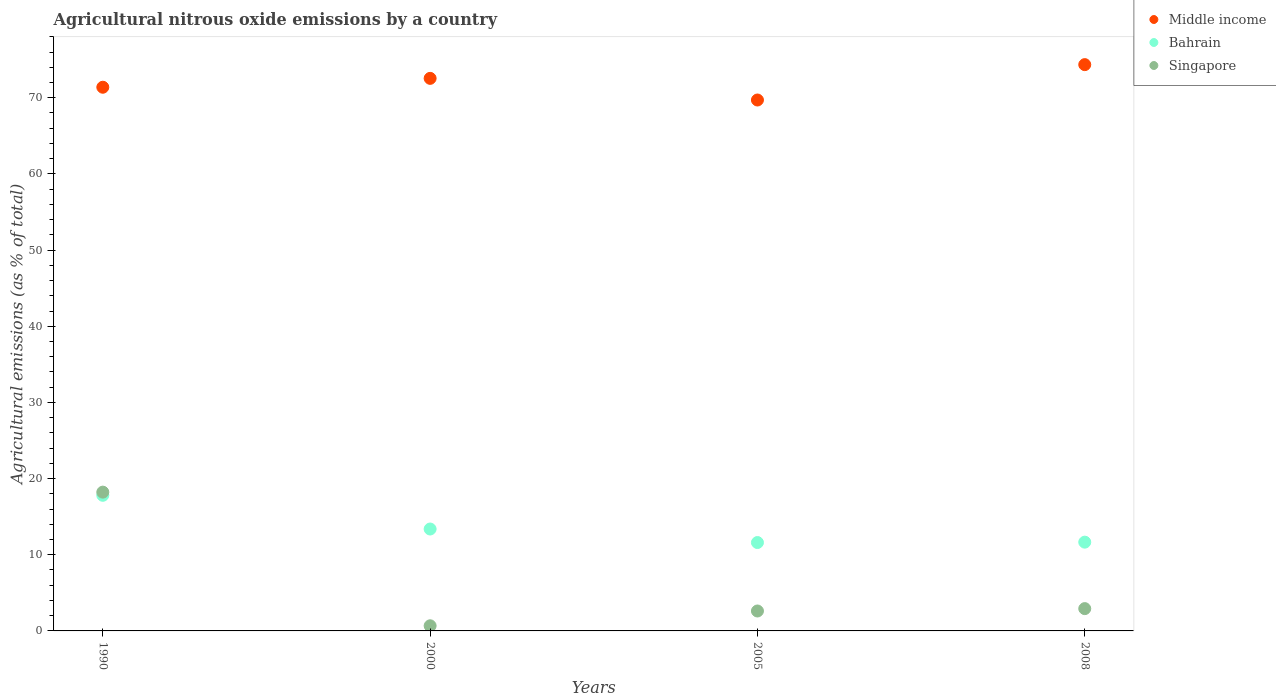Is the number of dotlines equal to the number of legend labels?
Offer a terse response. Yes. What is the amount of agricultural nitrous oxide emitted in Bahrain in 2005?
Your answer should be compact. 11.6. Across all years, what is the maximum amount of agricultural nitrous oxide emitted in Bahrain?
Offer a terse response. 17.81. Across all years, what is the minimum amount of agricultural nitrous oxide emitted in Singapore?
Your answer should be very brief. 0.67. In which year was the amount of agricultural nitrous oxide emitted in Middle income minimum?
Provide a short and direct response. 2005. What is the total amount of agricultural nitrous oxide emitted in Middle income in the graph?
Your answer should be very brief. 287.97. What is the difference between the amount of agricultural nitrous oxide emitted in Middle income in 2005 and that in 2008?
Make the answer very short. -4.64. What is the difference between the amount of agricultural nitrous oxide emitted in Middle income in 2000 and the amount of agricultural nitrous oxide emitted in Bahrain in 2008?
Your answer should be compact. 60.89. What is the average amount of agricultural nitrous oxide emitted in Bahrain per year?
Your answer should be compact. 13.61. In the year 2000, what is the difference between the amount of agricultural nitrous oxide emitted in Middle income and amount of agricultural nitrous oxide emitted in Singapore?
Keep it short and to the point. 71.87. In how many years, is the amount of agricultural nitrous oxide emitted in Singapore greater than 62 %?
Your response must be concise. 0. What is the ratio of the amount of agricultural nitrous oxide emitted in Middle income in 1990 to that in 2000?
Keep it short and to the point. 0.98. What is the difference between the highest and the second highest amount of agricultural nitrous oxide emitted in Middle income?
Offer a terse response. 1.8. What is the difference between the highest and the lowest amount of agricultural nitrous oxide emitted in Bahrain?
Provide a succinct answer. 6.2. Is the sum of the amount of agricultural nitrous oxide emitted in Middle income in 1990 and 2000 greater than the maximum amount of agricultural nitrous oxide emitted in Singapore across all years?
Your response must be concise. Yes. Is it the case that in every year, the sum of the amount of agricultural nitrous oxide emitted in Bahrain and amount of agricultural nitrous oxide emitted in Middle income  is greater than the amount of agricultural nitrous oxide emitted in Singapore?
Your answer should be very brief. Yes. Does the amount of agricultural nitrous oxide emitted in Middle income monotonically increase over the years?
Ensure brevity in your answer.  No. Is the amount of agricultural nitrous oxide emitted in Middle income strictly greater than the amount of agricultural nitrous oxide emitted in Bahrain over the years?
Offer a very short reply. Yes. What is the difference between two consecutive major ticks on the Y-axis?
Keep it short and to the point. 10. Are the values on the major ticks of Y-axis written in scientific E-notation?
Keep it short and to the point. No. Does the graph contain any zero values?
Provide a succinct answer. No. Does the graph contain grids?
Give a very brief answer. No. Where does the legend appear in the graph?
Your answer should be very brief. Top right. What is the title of the graph?
Make the answer very short. Agricultural nitrous oxide emissions by a country. What is the label or title of the X-axis?
Offer a very short reply. Years. What is the label or title of the Y-axis?
Offer a very short reply. Agricultural emissions (as % of total). What is the Agricultural emissions (as % of total) of Middle income in 1990?
Your answer should be compact. 71.38. What is the Agricultural emissions (as % of total) in Bahrain in 1990?
Offer a terse response. 17.81. What is the Agricultural emissions (as % of total) of Singapore in 1990?
Make the answer very short. 18.22. What is the Agricultural emissions (as % of total) in Middle income in 2000?
Make the answer very short. 72.54. What is the Agricultural emissions (as % of total) of Bahrain in 2000?
Keep it short and to the point. 13.38. What is the Agricultural emissions (as % of total) in Singapore in 2000?
Provide a succinct answer. 0.67. What is the Agricultural emissions (as % of total) in Middle income in 2005?
Offer a terse response. 69.7. What is the Agricultural emissions (as % of total) in Bahrain in 2005?
Provide a succinct answer. 11.6. What is the Agricultural emissions (as % of total) in Singapore in 2005?
Provide a short and direct response. 2.62. What is the Agricultural emissions (as % of total) in Middle income in 2008?
Your response must be concise. 74.35. What is the Agricultural emissions (as % of total) of Bahrain in 2008?
Provide a succinct answer. 11.65. What is the Agricultural emissions (as % of total) of Singapore in 2008?
Give a very brief answer. 2.93. Across all years, what is the maximum Agricultural emissions (as % of total) in Middle income?
Your answer should be compact. 74.35. Across all years, what is the maximum Agricultural emissions (as % of total) in Bahrain?
Provide a short and direct response. 17.81. Across all years, what is the maximum Agricultural emissions (as % of total) in Singapore?
Offer a very short reply. 18.22. Across all years, what is the minimum Agricultural emissions (as % of total) of Middle income?
Offer a terse response. 69.7. Across all years, what is the minimum Agricultural emissions (as % of total) of Bahrain?
Provide a short and direct response. 11.6. Across all years, what is the minimum Agricultural emissions (as % of total) in Singapore?
Make the answer very short. 0.67. What is the total Agricultural emissions (as % of total) in Middle income in the graph?
Your answer should be compact. 287.97. What is the total Agricultural emissions (as % of total) in Bahrain in the graph?
Give a very brief answer. 54.44. What is the total Agricultural emissions (as % of total) of Singapore in the graph?
Ensure brevity in your answer.  24.44. What is the difference between the Agricultural emissions (as % of total) of Middle income in 1990 and that in 2000?
Ensure brevity in your answer.  -1.17. What is the difference between the Agricultural emissions (as % of total) of Bahrain in 1990 and that in 2000?
Your answer should be compact. 4.43. What is the difference between the Agricultural emissions (as % of total) in Singapore in 1990 and that in 2000?
Make the answer very short. 17.55. What is the difference between the Agricultural emissions (as % of total) in Middle income in 1990 and that in 2005?
Your answer should be compact. 1.68. What is the difference between the Agricultural emissions (as % of total) of Bahrain in 1990 and that in 2005?
Make the answer very short. 6.2. What is the difference between the Agricultural emissions (as % of total) in Singapore in 1990 and that in 2005?
Your response must be concise. 15.6. What is the difference between the Agricultural emissions (as % of total) of Middle income in 1990 and that in 2008?
Your answer should be compact. -2.97. What is the difference between the Agricultural emissions (as % of total) of Bahrain in 1990 and that in 2008?
Provide a succinct answer. 6.15. What is the difference between the Agricultural emissions (as % of total) in Singapore in 1990 and that in 2008?
Your response must be concise. 15.29. What is the difference between the Agricultural emissions (as % of total) of Middle income in 2000 and that in 2005?
Your response must be concise. 2.84. What is the difference between the Agricultural emissions (as % of total) of Bahrain in 2000 and that in 2005?
Your response must be concise. 1.78. What is the difference between the Agricultural emissions (as % of total) of Singapore in 2000 and that in 2005?
Make the answer very short. -1.94. What is the difference between the Agricultural emissions (as % of total) of Middle income in 2000 and that in 2008?
Offer a very short reply. -1.8. What is the difference between the Agricultural emissions (as % of total) in Bahrain in 2000 and that in 2008?
Offer a very short reply. 1.72. What is the difference between the Agricultural emissions (as % of total) of Singapore in 2000 and that in 2008?
Provide a short and direct response. -2.25. What is the difference between the Agricultural emissions (as % of total) in Middle income in 2005 and that in 2008?
Keep it short and to the point. -4.64. What is the difference between the Agricultural emissions (as % of total) of Bahrain in 2005 and that in 2008?
Ensure brevity in your answer.  -0.05. What is the difference between the Agricultural emissions (as % of total) of Singapore in 2005 and that in 2008?
Your answer should be compact. -0.31. What is the difference between the Agricultural emissions (as % of total) of Middle income in 1990 and the Agricultural emissions (as % of total) of Bahrain in 2000?
Give a very brief answer. 58. What is the difference between the Agricultural emissions (as % of total) of Middle income in 1990 and the Agricultural emissions (as % of total) of Singapore in 2000?
Keep it short and to the point. 70.7. What is the difference between the Agricultural emissions (as % of total) of Bahrain in 1990 and the Agricultural emissions (as % of total) of Singapore in 2000?
Keep it short and to the point. 17.13. What is the difference between the Agricultural emissions (as % of total) in Middle income in 1990 and the Agricultural emissions (as % of total) in Bahrain in 2005?
Your answer should be very brief. 59.77. What is the difference between the Agricultural emissions (as % of total) of Middle income in 1990 and the Agricultural emissions (as % of total) of Singapore in 2005?
Provide a short and direct response. 68.76. What is the difference between the Agricultural emissions (as % of total) in Bahrain in 1990 and the Agricultural emissions (as % of total) in Singapore in 2005?
Provide a succinct answer. 15.19. What is the difference between the Agricultural emissions (as % of total) in Middle income in 1990 and the Agricultural emissions (as % of total) in Bahrain in 2008?
Your response must be concise. 59.72. What is the difference between the Agricultural emissions (as % of total) in Middle income in 1990 and the Agricultural emissions (as % of total) in Singapore in 2008?
Ensure brevity in your answer.  68.45. What is the difference between the Agricultural emissions (as % of total) in Bahrain in 1990 and the Agricultural emissions (as % of total) in Singapore in 2008?
Provide a succinct answer. 14.88. What is the difference between the Agricultural emissions (as % of total) in Middle income in 2000 and the Agricultural emissions (as % of total) in Bahrain in 2005?
Provide a succinct answer. 60.94. What is the difference between the Agricultural emissions (as % of total) of Middle income in 2000 and the Agricultural emissions (as % of total) of Singapore in 2005?
Give a very brief answer. 69.93. What is the difference between the Agricultural emissions (as % of total) of Bahrain in 2000 and the Agricultural emissions (as % of total) of Singapore in 2005?
Offer a very short reply. 10.76. What is the difference between the Agricultural emissions (as % of total) of Middle income in 2000 and the Agricultural emissions (as % of total) of Bahrain in 2008?
Provide a succinct answer. 60.89. What is the difference between the Agricultural emissions (as % of total) of Middle income in 2000 and the Agricultural emissions (as % of total) of Singapore in 2008?
Make the answer very short. 69.62. What is the difference between the Agricultural emissions (as % of total) of Bahrain in 2000 and the Agricultural emissions (as % of total) of Singapore in 2008?
Provide a short and direct response. 10.45. What is the difference between the Agricultural emissions (as % of total) of Middle income in 2005 and the Agricultural emissions (as % of total) of Bahrain in 2008?
Give a very brief answer. 58.05. What is the difference between the Agricultural emissions (as % of total) in Middle income in 2005 and the Agricultural emissions (as % of total) in Singapore in 2008?
Provide a succinct answer. 66.77. What is the difference between the Agricultural emissions (as % of total) in Bahrain in 2005 and the Agricultural emissions (as % of total) in Singapore in 2008?
Offer a terse response. 8.68. What is the average Agricultural emissions (as % of total) in Middle income per year?
Offer a terse response. 71.99. What is the average Agricultural emissions (as % of total) in Bahrain per year?
Keep it short and to the point. 13.61. What is the average Agricultural emissions (as % of total) in Singapore per year?
Offer a terse response. 6.11. In the year 1990, what is the difference between the Agricultural emissions (as % of total) of Middle income and Agricultural emissions (as % of total) of Bahrain?
Keep it short and to the point. 53.57. In the year 1990, what is the difference between the Agricultural emissions (as % of total) of Middle income and Agricultural emissions (as % of total) of Singapore?
Your answer should be compact. 53.16. In the year 1990, what is the difference between the Agricultural emissions (as % of total) of Bahrain and Agricultural emissions (as % of total) of Singapore?
Your response must be concise. -0.41. In the year 2000, what is the difference between the Agricultural emissions (as % of total) of Middle income and Agricultural emissions (as % of total) of Bahrain?
Provide a succinct answer. 59.16. In the year 2000, what is the difference between the Agricultural emissions (as % of total) in Middle income and Agricultural emissions (as % of total) in Singapore?
Offer a terse response. 71.87. In the year 2000, what is the difference between the Agricultural emissions (as % of total) in Bahrain and Agricultural emissions (as % of total) in Singapore?
Ensure brevity in your answer.  12.7. In the year 2005, what is the difference between the Agricultural emissions (as % of total) in Middle income and Agricultural emissions (as % of total) in Bahrain?
Ensure brevity in your answer.  58.1. In the year 2005, what is the difference between the Agricultural emissions (as % of total) of Middle income and Agricultural emissions (as % of total) of Singapore?
Provide a short and direct response. 67.09. In the year 2005, what is the difference between the Agricultural emissions (as % of total) of Bahrain and Agricultural emissions (as % of total) of Singapore?
Make the answer very short. 8.99. In the year 2008, what is the difference between the Agricultural emissions (as % of total) in Middle income and Agricultural emissions (as % of total) in Bahrain?
Your answer should be very brief. 62.69. In the year 2008, what is the difference between the Agricultural emissions (as % of total) in Middle income and Agricultural emissions (as % of total) in Singapore?
Make the answer very short. 71.42. In the year 2008, what is the difference between the Agricultural emissions (as % of total) of Bahrain and Agricultural emissions (as % of total) of Singapore?
Keep it short and to the point. 8.73. What is the ratio of the Agricultural emissions (as % of total) of Middle income in 1990 to that in 2000?
Make the answer very short. 0.98. What is the ratio of the Agricultural emissions (as % of total) of Bahrain in 1990 to that in 2000?
Your answer should be very brief. 1.33. What is the ratio of the Agricultural emissions (as % of total) of Singapore in 1990 to that in 2000?
Your answer should be very brief. 27.02. What is the ratio of the Agricultural emissions (as % of total) of Middle income in 1990 to that in 2005?
Your answer should be very brief. 1.02. What is the ratio of the Agricultural emissions (as % of total) in Bahrain in 1990 to that in 2005?
Provide a succinct answer. 1.53. What is the ratio of the Agricultural emissions (as % of total) in Singapore in 1990 to that in 2005?
Your response must be concise. 6.96. What is the ratio of the Agricultural emissions (as % of total) in Middle income in 1990 to that in 2008?
Provide a succinct answer. 0.96. What is the ratio of the Agricultural emissions (as % of total) of Bahrain in 1990 to that in 2008?
Keep it short and to the point. 1.53. What is the ratio of the Agricultural emissions (as % of total) of Singapore in 1990 to that in 2008?
Offer a terse response. 6.22. What is the ratio of the Agricultural emissions (as % of total) of Middle income in 2000 to that in 2005?
Provide a succinct answer. 1.04. What is the ratio of the Agricultural emissions (as % of total) of Bahrain in 2000 to that in 2005?
Offer a very short reply. 1.15. What is the ratio of the Agricultural emissions (as % of total) of Singapore in 2000 to that in 2005?
Ensure brevity in your answer.  0.26. What is the ratio of the Agricultural emissions (as % of total) of Middle income in 2000 to that in 2008?
Keep it short and to the point. 0.98. What is the ratio of the Agricultural emissions (as % of total) of Bahrain in 2000 to that in 2008?
Provide a succinct answer. 1.15. What is the ratio of the Agricultural emissions (as % of total) of Singapore in 2000 to that in 2008?
Your answer should be very brief. 0.23. What is the ratio of the Agricultural emissions (as % of total) of Middle income in 2005 to that in 2008?
Provide a succinct answer. 0.94. What is the ratio of the Agricultural emissions (as % of total) of Singapore in 2005 to that in 2008?
Provide a succinct answer. 0.89. What is the difference between the highest and the second highest Agricultural emissions (as % of total) in Middle income?
Your answer should be very brief. 1.8. What is the difference between the highest and the second highest Agricultural emissions (as % of total) in Bahrain?
Provide a succinct answer. 4.43. What is the difference between the highest and the second highest Agricultural emissions (as % of total) of Singapore?
Your answer should be compact. 15.29. What is the difference between the highest and the lowest Agricultural emissions (as % of total) of Middle income?
Offer a very short reply. 4.64. What is the difference between the highest and the lowest Agricultural emissions (as % of total) of Bahrain?
Offer a terse response. 6.2. What is the difference between the highest and the lowest Agricultural emissions (as % of total) of Singapore?
Provide a short and direct response. 17.55. 